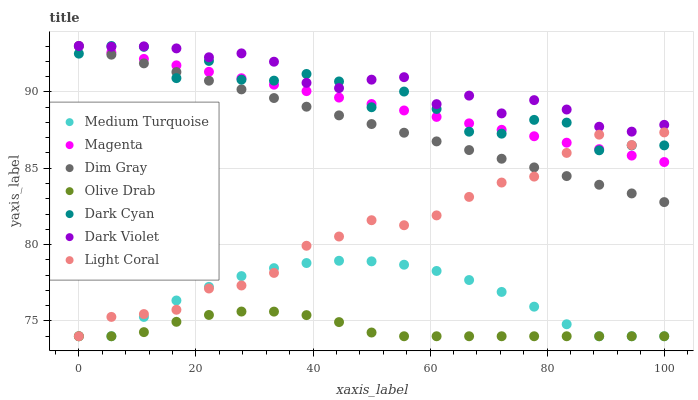Does Olive Drab have the minimum area under the curve?
Answer yes or no. Yes. Does Dark Violet have the maximum area under the curve?
Answer yes or no. Yes. Does Light Coral have the minimum area under the curve?
Answer yes or no. No. Does Light Coral have the maximum area under the curve?
Answer yes or no. No. Is Magenta the smoothest?
Answer yes or no. Yes. Is Dark Cyan the roughest?
Answer yes or no. Yes. Is Dark Violet the smoothest?
Answer yes or no. No. Is Dark Violet the roughest?
Answer yes or no. No. Does Light Coral have the lowest value?
Answer yes or no. Yes. Does Dark Violet have the lowest value?
Answer yes or no. No. Does Magenta have the highest value?
Answer yes or no. Yes. Does Light Coral have the highest value?
Answer yes or no. No. Is Medium Turquoise less than Dim Gray?
Answer yes or no. Yes. Is Magenta greater than Medium Turquoise?
Answer yes or no. Yes. Does Dim Gray intersect Dark Cyan?
Answer yes or no. Yes. Is Dim Gray less than Dark Cyan?
Answer yes or no. No. Is Dim Gray greater than Dark Cyan?
Answer yes or no. No. Does Medium Turquoise intersect Dim Gray?
Answer yes or no. No. 